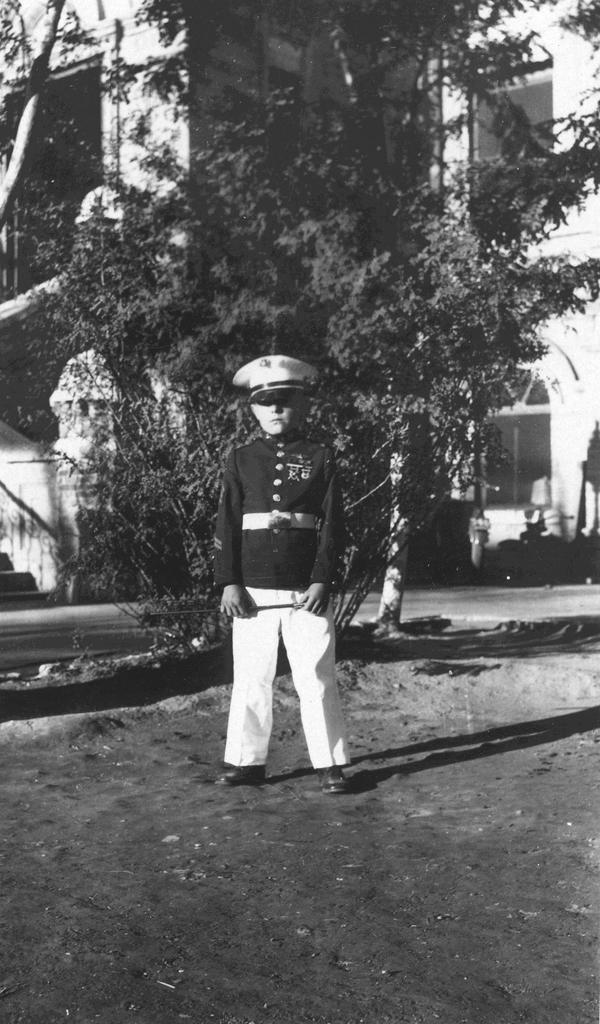What is the color scheme of the image? The image is black and white. Who is present in the image? There is a boy in the image. What is the boy wearing? The boy is wearing a uniform and a cap. What can be seen in the background of the image? There are trees and a building in the background of the image. What type of voice can be heard coming from the boy in the image? There is no sound or voice present in the image, as it is a still photograph. 